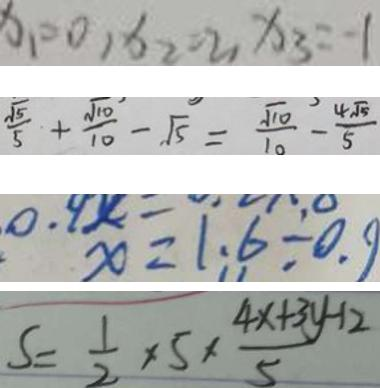<formula> <loc_0><loc_0><loc_500><loc_500>x _ { 1 } = 0 , x _ { 2 } = 2 , x _ { 3 } = - 1 
 \frac { \sqrt { 5 } } { 5 } + \frac { \sqrt { 1 0 } } { 1 0 } - \sqrt { 5 } = \frac { \sqrt { 1 0 } } { 1 0 } - \frac { 4 \sqrt { 5 } } { 5 } 
 x \times = 1 . 6 \div 0 . 9 
 S = \frac { 1 } { 2 } \times 5 \times \frac { 4 x + 3 y - 1 2 } { 5 }</formula> 